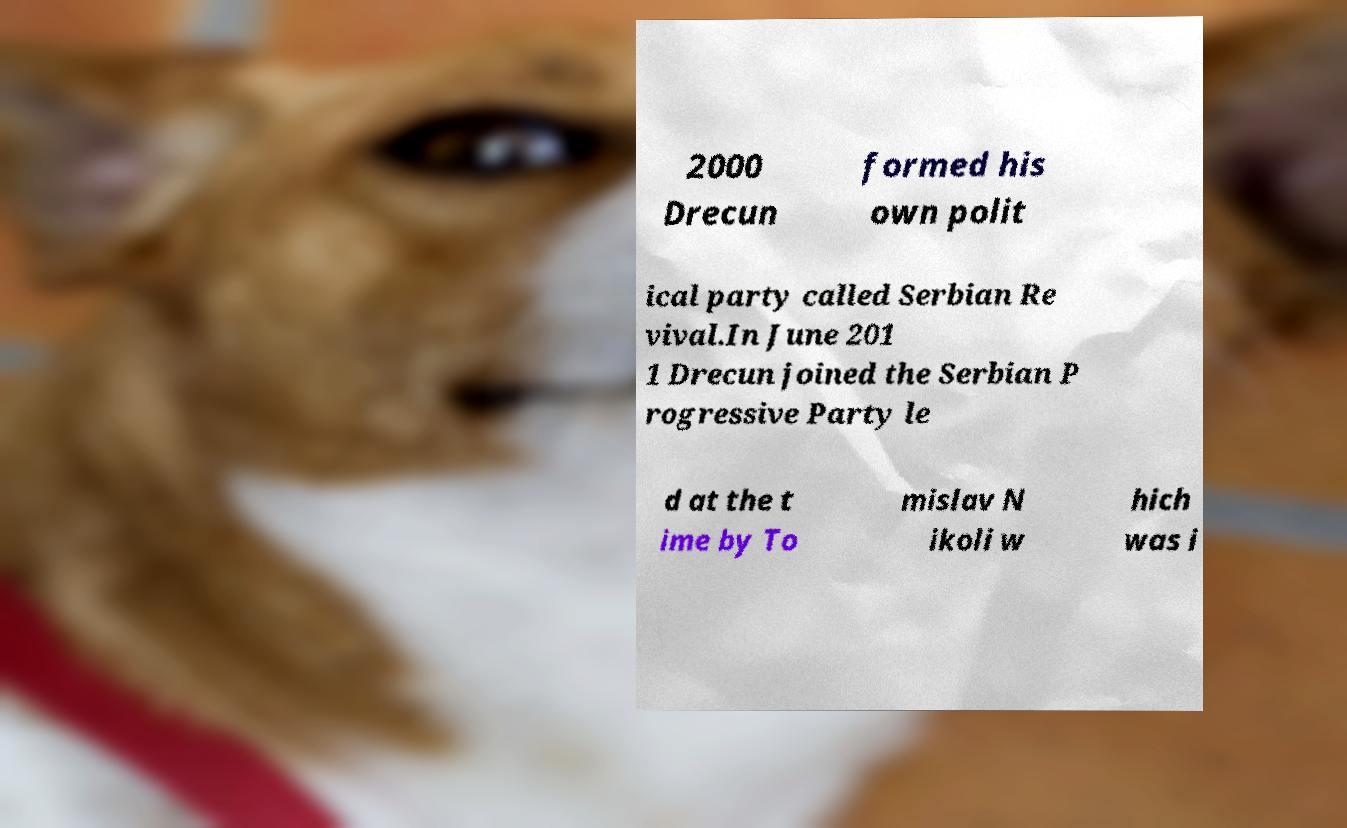What messages or text are displayed in this image? I need them in a readable, typed format. 2000 Drecun formed his own polit ical party called Serbian Re vival.In June 201 1 Drecun joined the Serbian P rogressive Party le d at the t ime by To mislav N ikoli w hich was i 